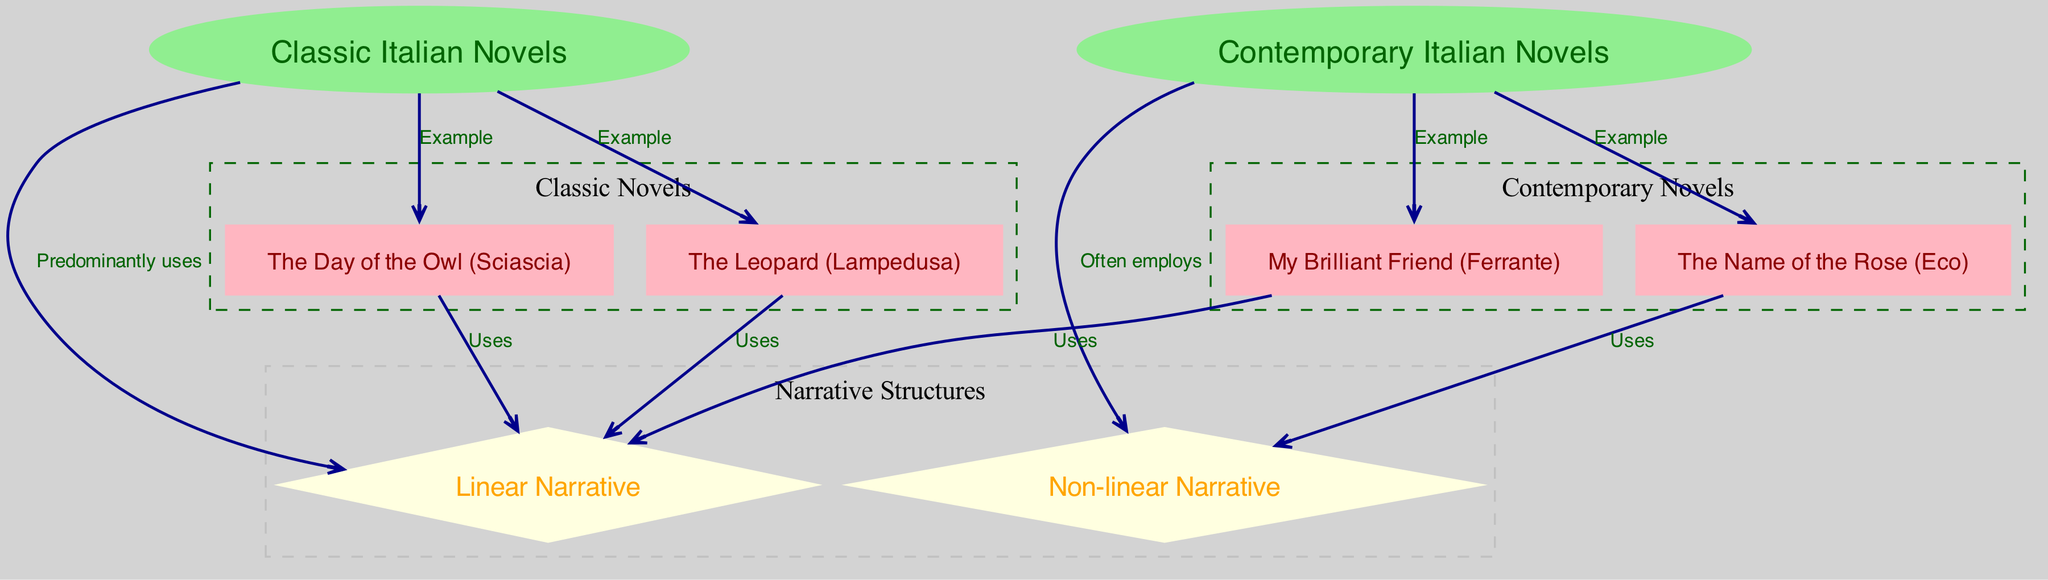What are the two main categories of novels represented in the diagram? The diagram features two primary categories of novels: Classic Italian Novels and Contemporary Italian Novels. These are distinctly labeled as nodes "1" and "2" respectively.
Answer: Classic Italian Novels, Contemporary Italian Novels How many nodes are there in total within the diagram? By counting the nodes listed in the data, we find there are eight in total: two categories of novels, two types of narratives, and four specific novel examples.
Answer: 8 Which narrative structure is predominantly used in classic Italian novels? The edge from node "1" (Classic Italian Novels) to node "3" (Linear Narrative) is labeled "Predominantly uses," indicating that classic novels tend to follow a linear narrative structure.
Answer: Linear Narrative Can you name an example of a contemporary Italian novel that employs non-linear narrative? Among the examples of contemporary Italian novels, the edge from node "7" (The Name of the Rose) to node "4" (Non-linear Narrative) indicates it uses this structure, confirming it as an example of a contemporary novel with a non-linear approach.
Answer: The Name of the Rose Which classic novel is an example of a linear narrative? The edges from nodes "5" (The Leopard) and "6" (The Day of the Owl) both connect to node "3" (Linear Narrative) and are labeled "Uses," denoting that both novels exemplify linear narrative forms within the classic category.
Answer: The Leopard, The Day of the Owl How many examples of contemporary novels are provided in the diagram? The counts of edges connecting from node "2" indicate two examples of contemporary novels, namely "The Name of the Rose" and "My Brilliant Friend." This confirms that there are indeed two examples labeled as contemporary novels.
Answer: 2 What narrative structure is often employed in contemporary Italian novels? The edge from node "2" (Contemporary Italian Novels) to node "4" (Non-linear Narrative) is labeled "Often employs." This demonstrates that contemporary novels frequently utilize a non-linear narrative approach.
Answer: Non-linear Narrative Which type of narrative does "My Brilliant Friend" use? The edge from node "8" (My Brilliant Friend) connects to node "3" (Linear Narrative) labeled "Uses," which confirms that "My Brilliant Friend" employs a linear narrative structure.
Answer: Linear Narrative 